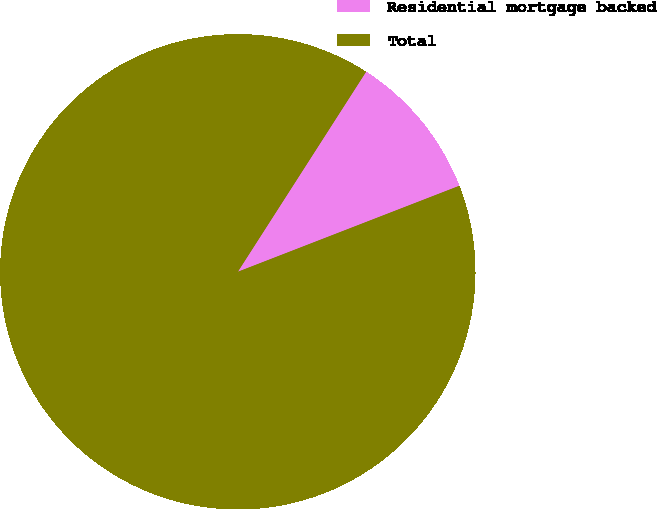Convert chart to OTSL. <chart><loc_0><loc_0><loc_500><loc_500><pie_chart><fcel>Residential mortgage backed<fcel>Total<nl><fcel>10.03%<fcel>89.97%<nl></chart> 